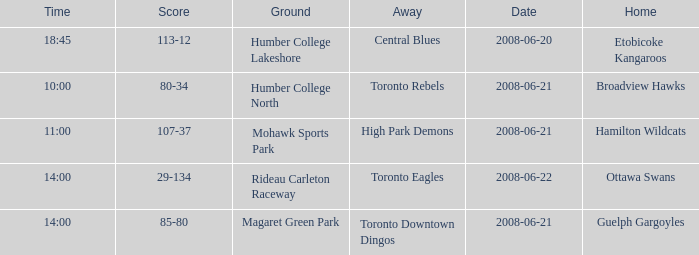What is the Date with a Home that is hamilton wildcats? 2008-06-21. 